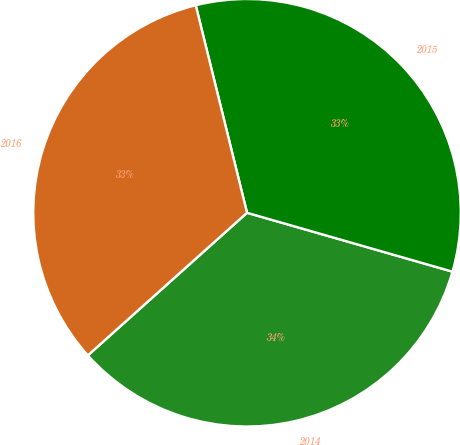<chart> <loc_0><loc_0><loc_500><loc_500><pie_chart><fcel>2014<fcel>2015<fcel>2016<nl><fcel>33.93%<fcel>33.3%<fcel>32.77%<nl></chart> 